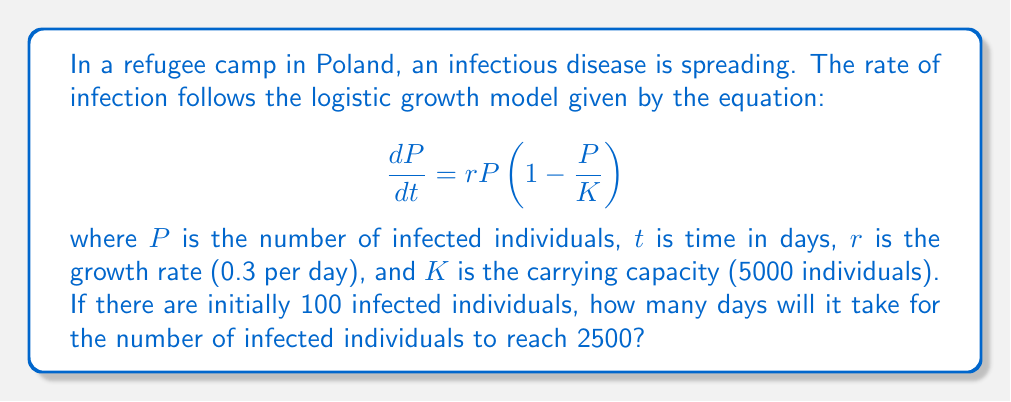What is the answer to this math problem? To solve this problem, we need to use the integrated form of the logistic growth equation:

$$P(t) = \frac{K}{1 + (\frac{K}{P_0} - 1)e^{-rt}}$$

Where:
$P(t)$ is the number of infected individuals at time $t$
$K = 5000$ (carrying capacity)
$P_0 = 100$ (initial number of infected individuals)
$r = 0.3$ (growth rate per day)

We want to find $t$ when $P(t) = 2500$. Let's solve step by step:

1) Substitute the known values into the equation:

   $$2500 = \frac{5000}{1 + (\frac{5000}{100} - 1)e^{-0.3t}}$$

2) Simplify:

   $$2500 = \frac{5000}{1 + 49e^{-0.3t}}$$

3) Multiply both sides by $(1 + 49e^{-0.3t})$:

   $$2500(1 + 49e^{-0.3t}) = 5000$$

4) Expand:

   $$2500 + 122500e^{-0.3t} = 5000$$

5) Subtract 2500 from both sides:

   $$122500e^{-0.3t} = 2500$$

6) Divide both sides by 122500:

   $$e^{-0.3t} = \frac{2500}{122500} = \frac{1}{49}$$

7) Take the natural log of both sides:

   $$-0.3t = \ln(\frac{1}{49})$$

8) Divide both sides by -0.3:

   $$t = -\frac{\ln(\frac{1}{49})}{0.3} \approx 13.03$$

Therefore, it will take approximately 13.03 days for the number of infected individuals to reach 2500.
Answer: 13.03 days 